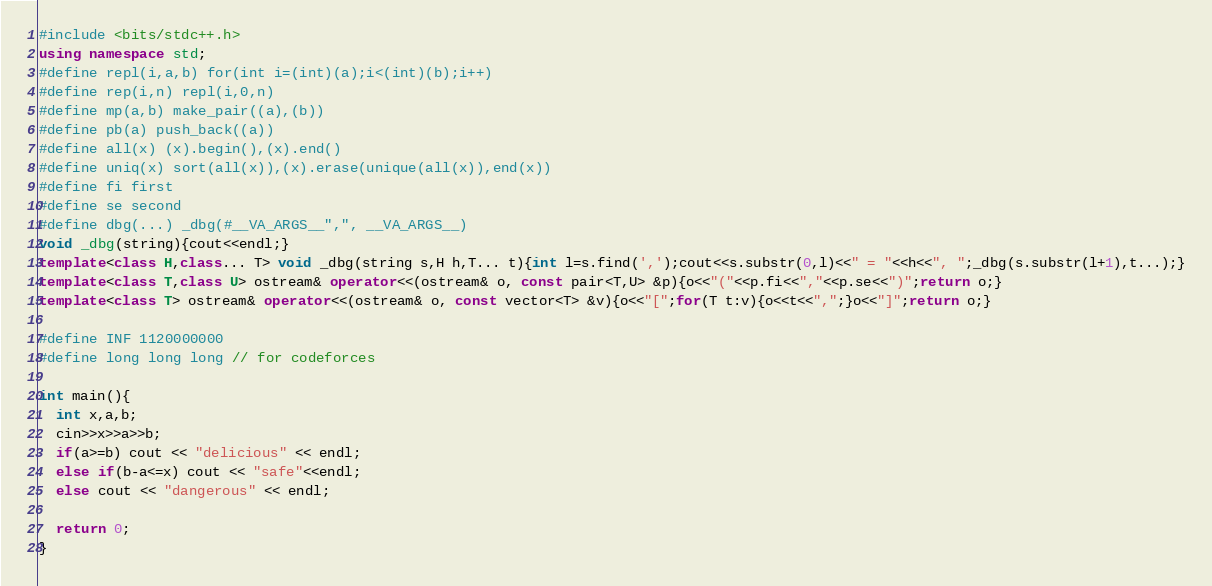<code> <loc_0><loc_0><loc_500><loc_500><_C++_>#include <bits/stdc++.h>
using namespace std;
#define repl(i,a,b) for(int i=(int)(a);i<(int)(b);i++)
#define rep(i,n) repl(i,0,n)
#define mp(a,b) make_pair((a),(b))
#define pb(a) push_back((a))
#define all(x) (x).begin(),(x).end()
#define uniq(x) sort(all(x)),(x).erase(unique(all(x)),end(x))
#define fi first
#define se second
#define dbg(...) _dbg(#__VA_ARGS__",", __VA_ARGS__)
void _dbg(string){cout<<endl;}
template<class H,class... T> void _dbg(string s,H h,T... t){int l=s.find(',');cout<<s.substr(0,l)<<" = "<<h<<", ";_dbg(s.substr(l+1),t...);}
template<class T,class U> ostream& operator<<(ostream& o, const pair<T,U> &p){o<<"("<<p.fi<<","<<p.se<<")";return o;}
template<class T> ostream& operator<<(ostream& o, const vector<T> &v){o<<"[";for(T t:v){o<<t<<",";}o<<"]";return o;}

#define INF 1120000000
#define long long long // for codeforces

int main(){
  int x,a,b;
  cin>>x>>a>>b;
  if(a>=b) cout << "delicious" << endl;
  else if(b-a<=x) cout << "safe"<<endl;
  else cout << "dangerous" << endl;

  return 0;
}
</code> 